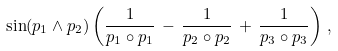<formula> <loc_0><loc_0><loc_500><loc_500>\sin ( p _ { 1 } \wedge p _ { 2 } ) \left ( \frac { 1 } { p _ { 1 } \circ p _ { 1 } } \, - \, \frac { 1 } { p _ { 2 } \circ p _ { 2 } } \, + \, \frac { 1 } { p _ { 3 } \circ p _ { 3 } } \right ) \, ,</formula> 